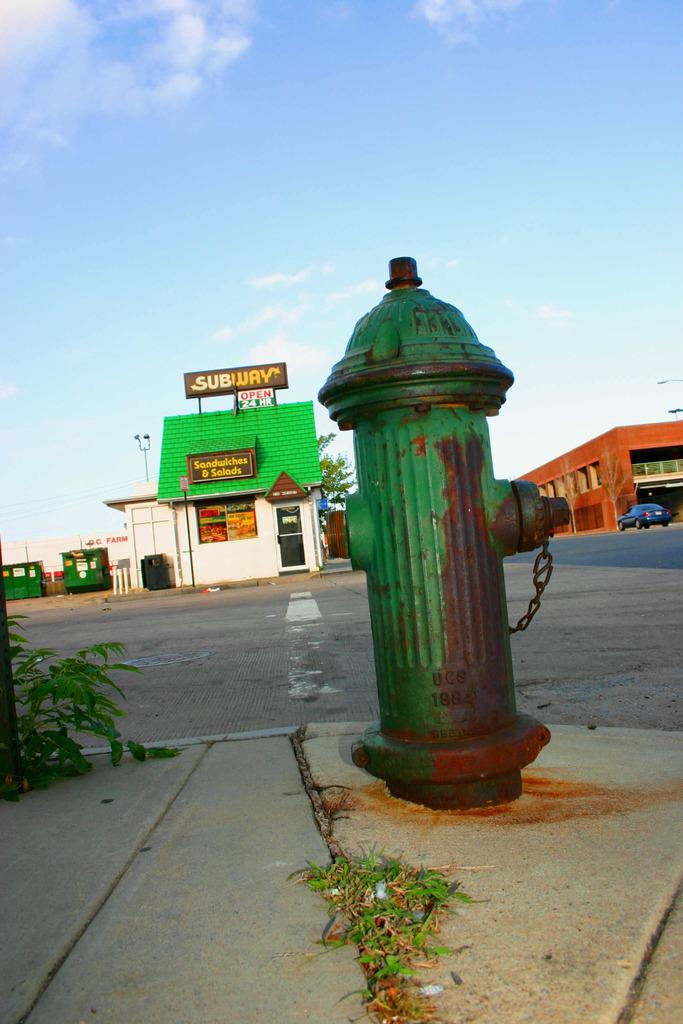<image>
Provide a brief description of the given image. A Subway restaurant is across the street from a green fire hydrant. 